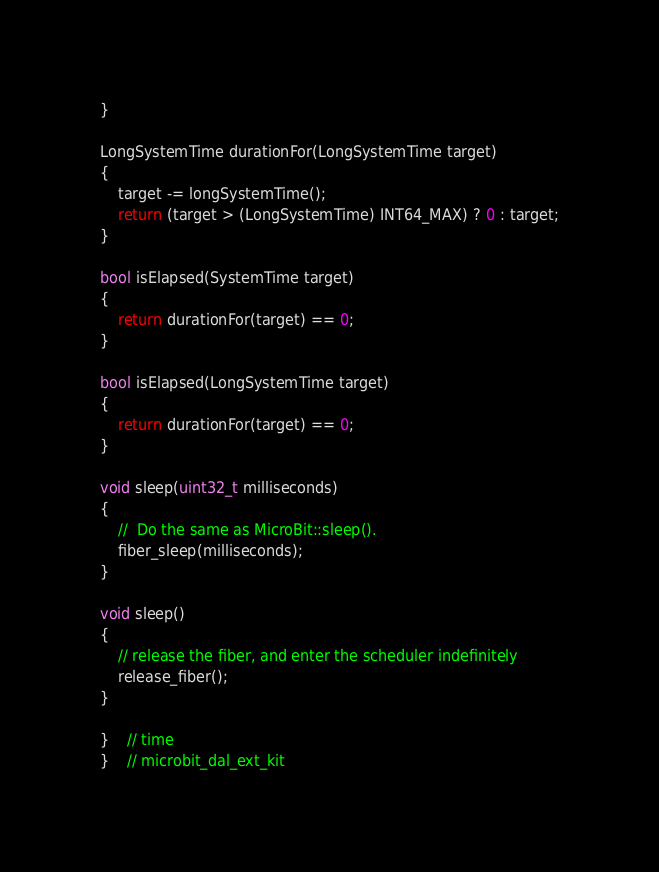<code> <loc_0><loc_0><loc_500><loc_500><_C++_>}

LongSystemTime durationFor(LongSystemTime target)
{
	target -= longSystemTime();
	return (target > (LongSystemTime) INT64_MAX) ? 0 : target;
}

bool isElapsed(SystemTime target)
{
	return durationFor(target) == 0;
}

bool isElapsed(LongSystemTime target)
{
	return durationFor(target) == 0;
}

void sleep(uint32_t milliseconds)
{
	//	Do the same as MicroBit::sleep().
	fiber_sleep(milliseconds);
}

void sleep()
{
	// release the fiber, and enter the scheduler indefinitely
	release_fiber();
}

}	// time
}	// microbit_dal_ext_kit
</code> 